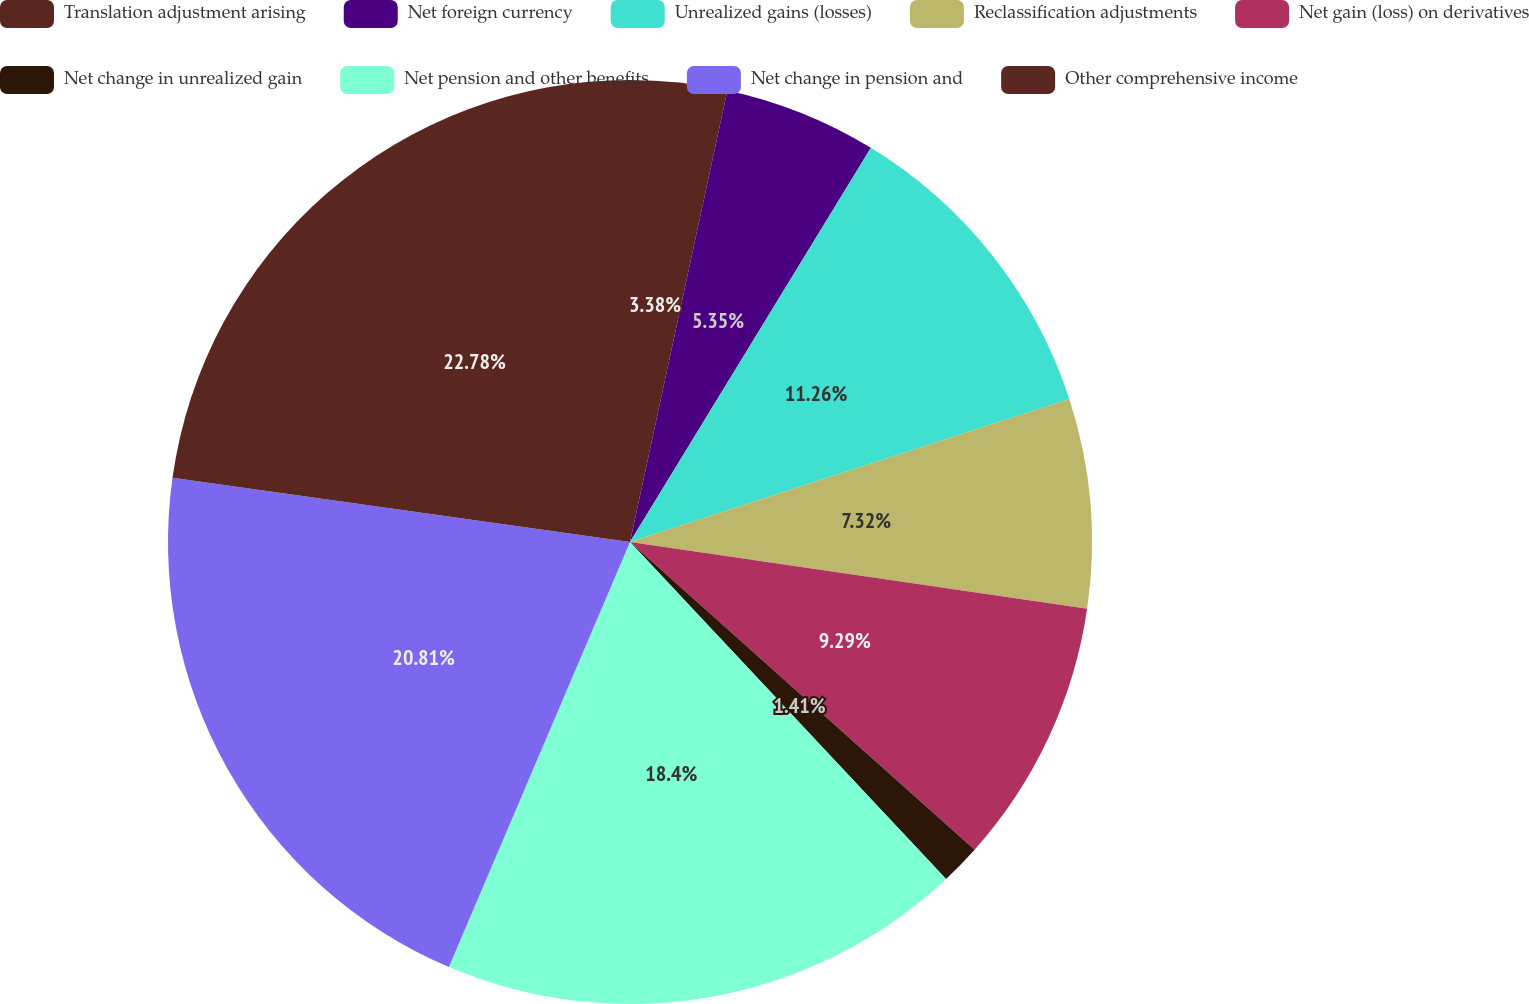Convert chart. <chart><loc_0><loc_0><loc_500><loc_500><pie_chart><fcel>Translation adjustment arising<fcel>Net foreign currency<fcel>Unrealized gains (losses)<fcel>Reclassification adjustments<fcel>Net gain (loss) on derivatives<fcel>Net change in unrealized gain<fcel>Net pension and other benefits<fcel>Net change in pension and<fcel>Other comprehensive income<nl><fcel>3.38%<fcel>5.35%<fcel>11.26%<fcel>7.32%<fcel>9.29%<fcel>1.41%<fcel>18.4%<fcel>20.81%<fcel>22.78%<nl></chart> 